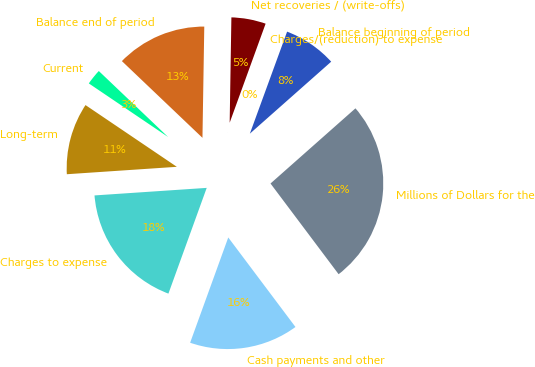<chart> <loc_0><loc_0><loc_500><loc_500><pie_chart><fcel>Millions of Dollars for the<fcel>Balance beginning of period<fcel>Charges/(reduction) to expense<fcel>Net recoveries / (write-offs)<fcel>Balance end of period<fcel>Current<fcel>Long-term<fcel>Charges to expense<fcel>Cash payments and other<nl><fcel>26.28%<fcel>7.9%<fcel>0.03%<fcel>5.28%<fcel>13.15%<fcel>2.65%<fcel>10.53%<fcel>18.4%<fcel>15.78%<nl></chart> 